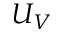Convert formula to latex. <formula><loc_0><loc_0><loc_500><loc_500>U _ { V }</formula> 